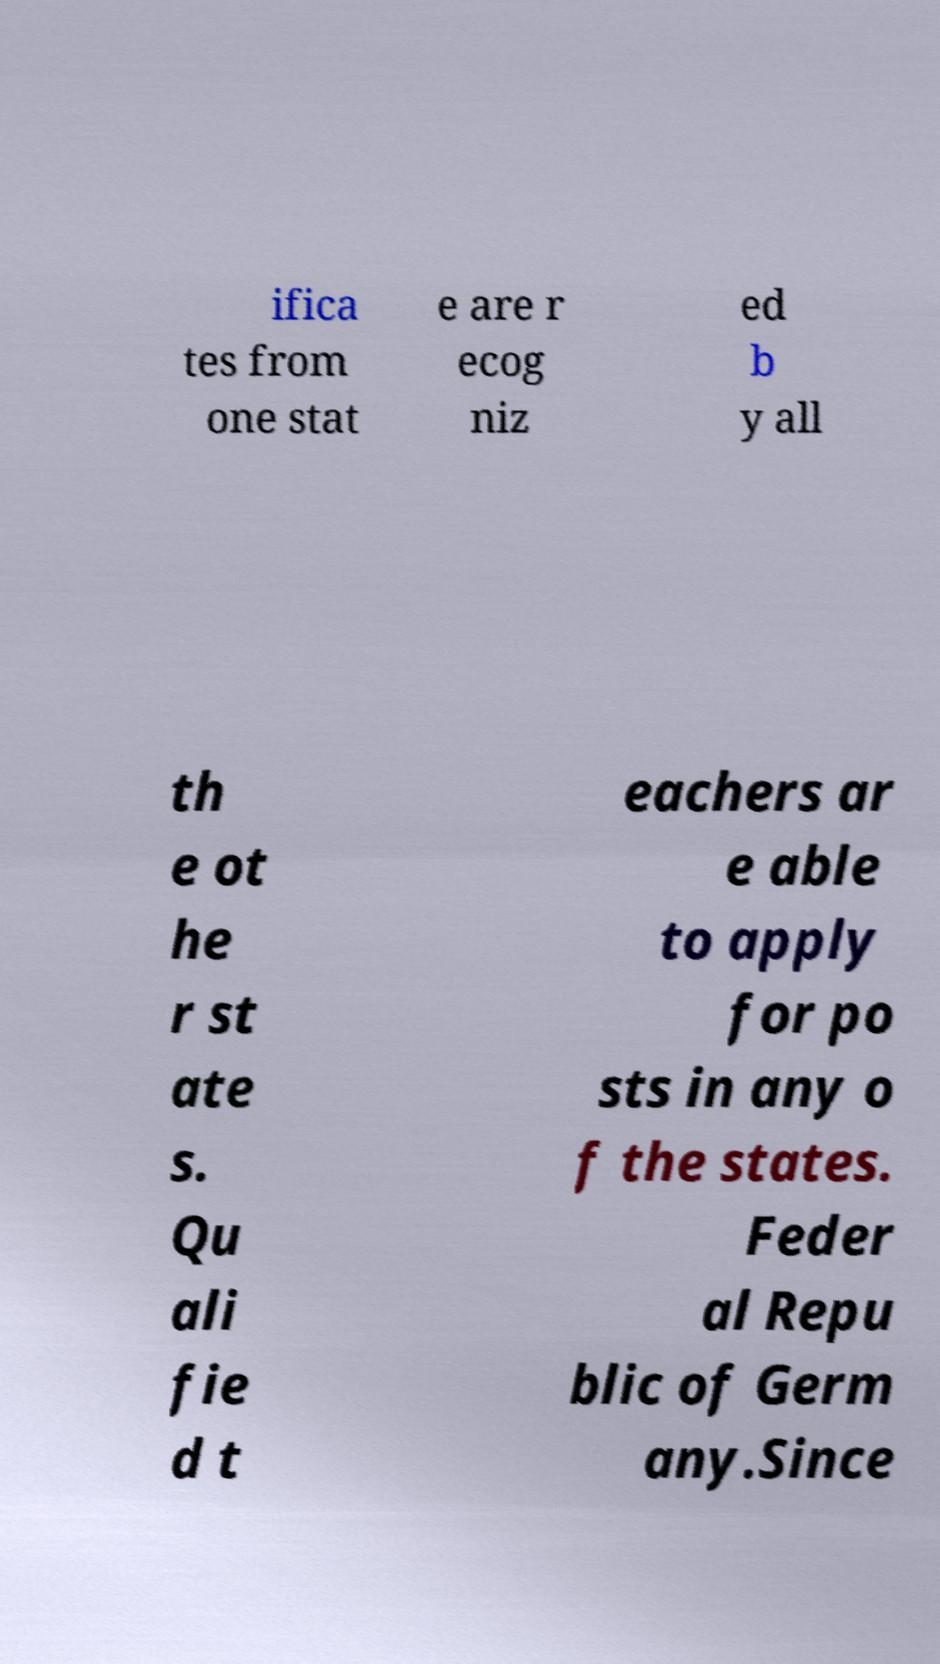What messages or text are displayed in this image? I need them in a readable, typed format. ifica tes from one stat e are r ecog niz ed b y all th e ot he r st ate s. Qu ali fie d t eachers ar e able to apply for po sts in any o f the states. Feder al Repu blic of Germ any.Since 